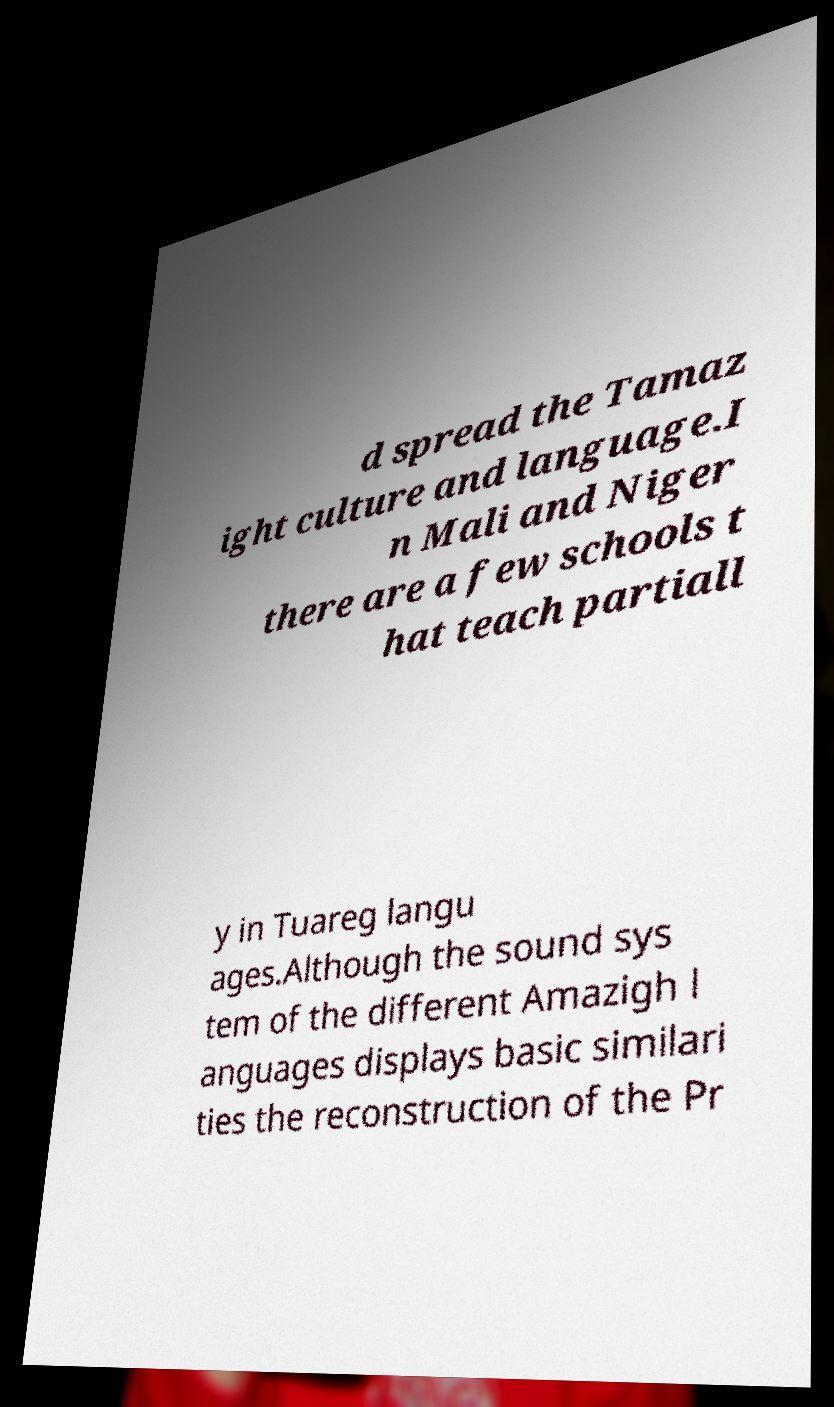Please read and relay the text visible in this image. What does it say? d spread the Tamaz ight culture and language.I n Mali and Niger there are a few schools t hat teach partiall y in Tuareg langu ages.Although the sound sys tem of the different Amazigh l anguages displays basic similari ties the reconstruction of the Pr 